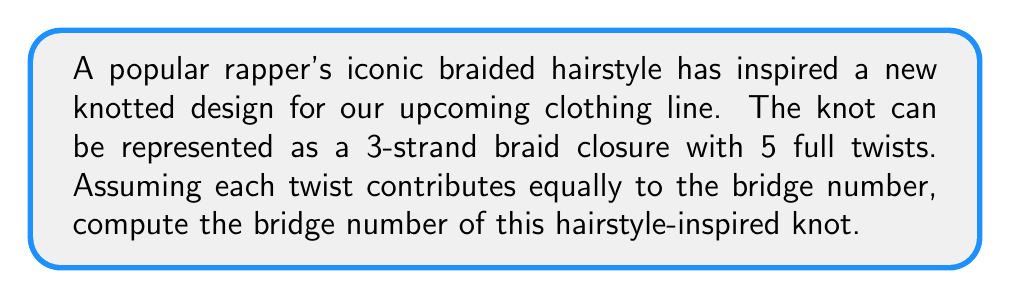Could you help me with this problem? Let's approach this step-by-step:

1) First, recall that for a braid closure, the bridge number is related to the number of strands in the braid. For an n-strand braid closure, the bridge number is at most n.

2) In this case, we have a 3-strand braid, so the maximum possible bridge number is 3.

3) However, we need to consider the number of twists. Each full twist in a 3-strand braid corresponds to the braid word $\sigma_1\sigma_2\sigma_1$ or its inverse.

4) The braid word for 5 full twists would be $(\sigma_1\sigma_2\sigma_1)^5$ or its inverse.

5) For 3-strand braids, the bridge number is always 2 or 3, regardless of the number of twists, unless the braid closure results in a trivial knot.

6) In this case, with 5 full twists, the resulting knot is non-trivial and cannot be isotoped to have fewer than 3 bridges.

7) Therefore, the bridge number of this knot is 3.

This means that in any projection of this knot, there will always be at least 3 overpasses (or 3 underpasses), which could be an interesting design element for the clothing line.
Answer: 3 